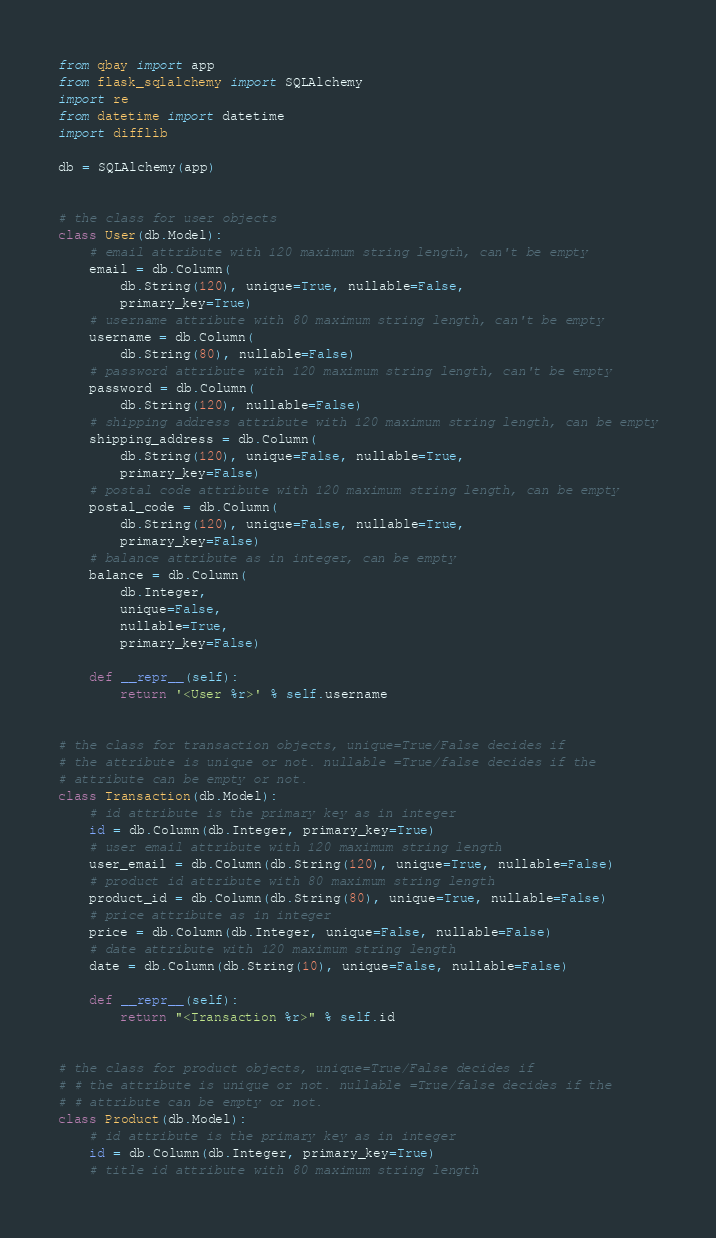Convert code to text. <code><loc_0><loc_0><loc_500><loc_500><_Python_>from qbay import app
from flask_sqlalchemy import SQLAlchemy
import re
from datetime import datetime
import difflib

db = SQLAlchemy(app)


# the class for user objects
class User(db.Model):
    # email attribute with 120 maximum string length, can't be empty
    email = db.Column(
        db.String(120), unique=True, nullable=False,
        primary_key=True)
    # username attribute with 80 maximum string length, can't be empty
    username = db.Column(
        db.String(80), nullable=False)
    # password attribute with 120 maximum string length, can't be empty
    password = db.Column(
        db.String(120), nullable=False)
    # shipping address attribute with 120 maximum string length, can be empty
    shipping_address = db.Column(
        db.String(120), unique=False, nullable=True,
        primary_key=False)
    # postal code attribute with 120 maximum string length, can be empty
    postal_code = db.Column(
        db.String(120), unique=False, nullable=True,
        primary_key=False)
    # balance attribute as in integer, can be empty
    balance = db.Column(
        db.Integer,
        unique=False,
        nullable=True,
        primary_key=False)

    def __repr__(self):
        return '<User %r>' % self.username


# the class for transaction objects, unique=True/False decides if
# the attribute is unique or not. nullable =True/false decides if the
# attribute can be empty or not.
class Transaction(db.Model):
    # id attribute is the primary key as in integer
    id = db.Column(db.Integer, primary_key=True)
    # user email attribute with 120 maximum string length
    user_email = db.Column(db.String(120), unique=True, nullable=False)
    # product id attribute with 80 maximum string length
    product_id = db.Column(db.String(80), unique=True, nullable=False)
    # price attribute as in integer
    price = db.Column(db.Integer, unique=False, nullable=False)
    # date attribute with 120 maximum string length
    date = db.Column(db.String(10), unique=False, nullable=False)

    def __repr__(self):
        return "<Transaction %r>" % self.id


# the class for product objects, unique=True/False decides if
# # the attribute is unique or not. nullable =True/false decides if the
# # attribute can be empty or not.
class Product(db.Model):
    # id attribute is the primary key as in integer
    id = db.Column(db.Integer, primary_key=True)
    # title id attribute with 80 maximum string length</code> 